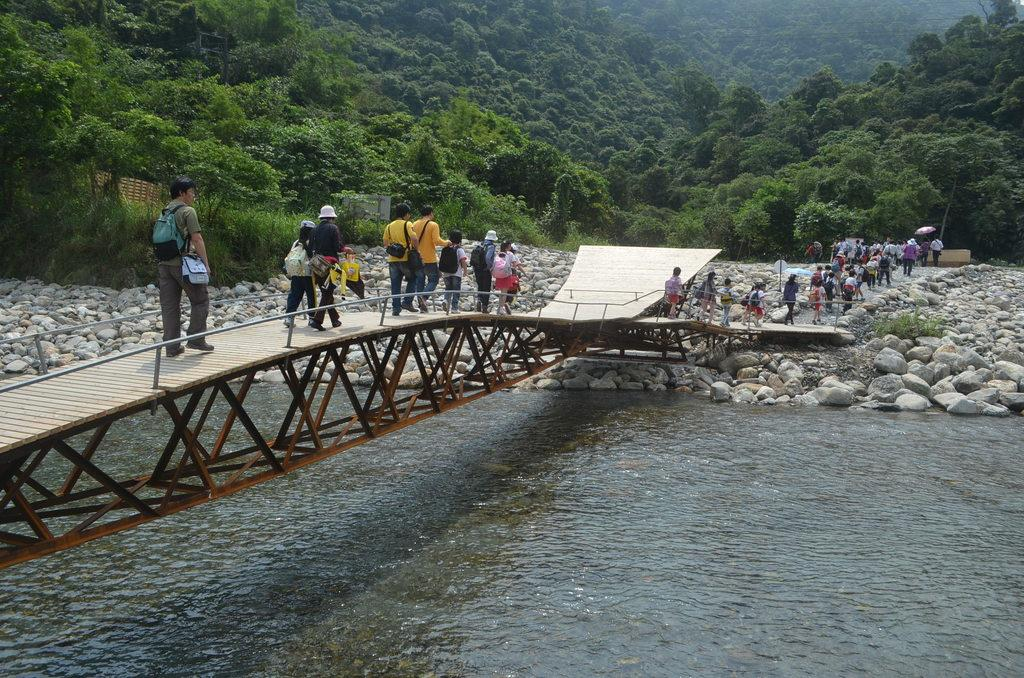What is the primary element present in the image? There is water in the image. What else can be seen in the image besides water? There are stones, people carrying bags and walking on a bridge, people on the ground, objects, and trees in the background. Can you describe the people in the image? The people in the image are carrying bags and walking on a bridge or standing on the ground. What is the setting of the image? The image features a bridge over water, with trees in the background. What type of record can be seen spinning on a turntable in the image? There is no record or turntable present in the image. 